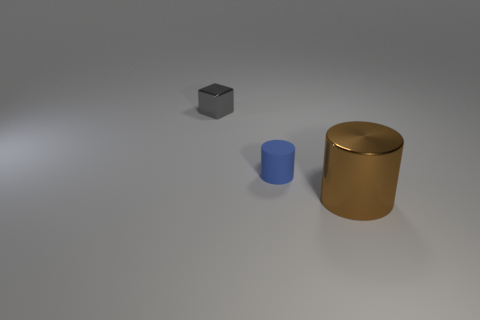There is a tiny object that is to the left of the small blue thing; what material is it?
Offer a very short reply. Metal. Is there another shiny cylinder that has the same size as the brown shiny cylinder?
Ensure brevity in your answer.  No. Is the shape of the large shiny object the same as the metallic object that is behind the big thing?
Make the answer very short. No. There is a metallic thing that is on the right side of the tiny gray shiny object; is it the same size as the cube that is behind the blue matte cylinder?
Keep it short and to the point. No. What number of other things are there of the same shape as the tiny gray thing?
Your answer should be compact. 0. There is a cylinder that is behind the thing to the right of the small rubber cylinder; what is it made of?
Your answer should be very brief. Rubber. What number of metallic things are either yellow balls or brown objects?
Your response must be concise. 1. Are there any other things that are the same material as the brown thing?
Provide a succinct answer. Yes. Is there a tiny metal thing that is in front of the object that is to the left of the small rubber cylinder?
Provide a short and direct response. No. What number of things are cylinders that are behind the large shiny thing or tiny objects right of the gray block?
Keep it short and to the point. 1. 